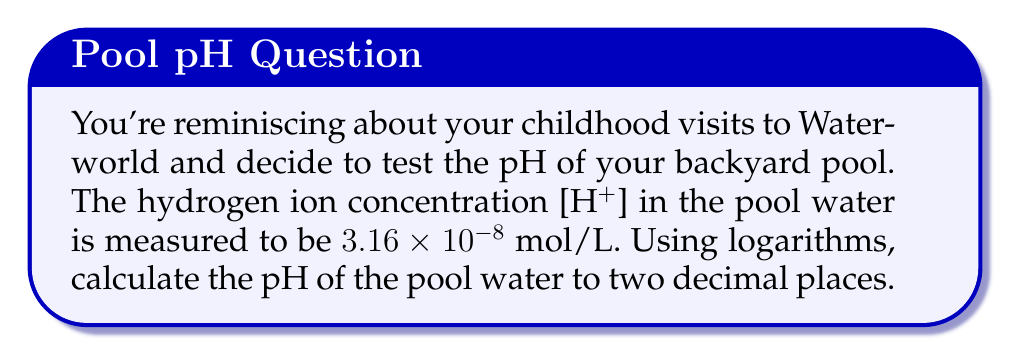What is the answer to this math problem? To solve this problem, we'll follow these steps:

1. Recall the formula for pH:
   $$ pH = -\log_{10}[H^+] $$

2. We're given $[H^+] = 3.16 \times 10^{-8}$ mol/L

3. Substitute this value into the pH formula:
   $$ pH = -\log_{10}(3.16 \times 10^{-8}) $$

4. Use the logarithm property $\log(a \times 10^n) = \log(a) + n$:
   $$ pH = -(\log_{10}(3.16) + \log_{10}(10^{-8})) $$
   $$ pH = -(\log_{10}(3.16) - 8) $$

5. Calculate $\log_{10}(3.16)$ using a calculator:
   $$ pH = -(0.4997 - 8) $$

6. Simplify:
   $$ pH = -0.4997 + 8 = 7.5003 $$

7. Round to two decimal places:
   $$ pH = 7.50 $$
Answer: 7.50 